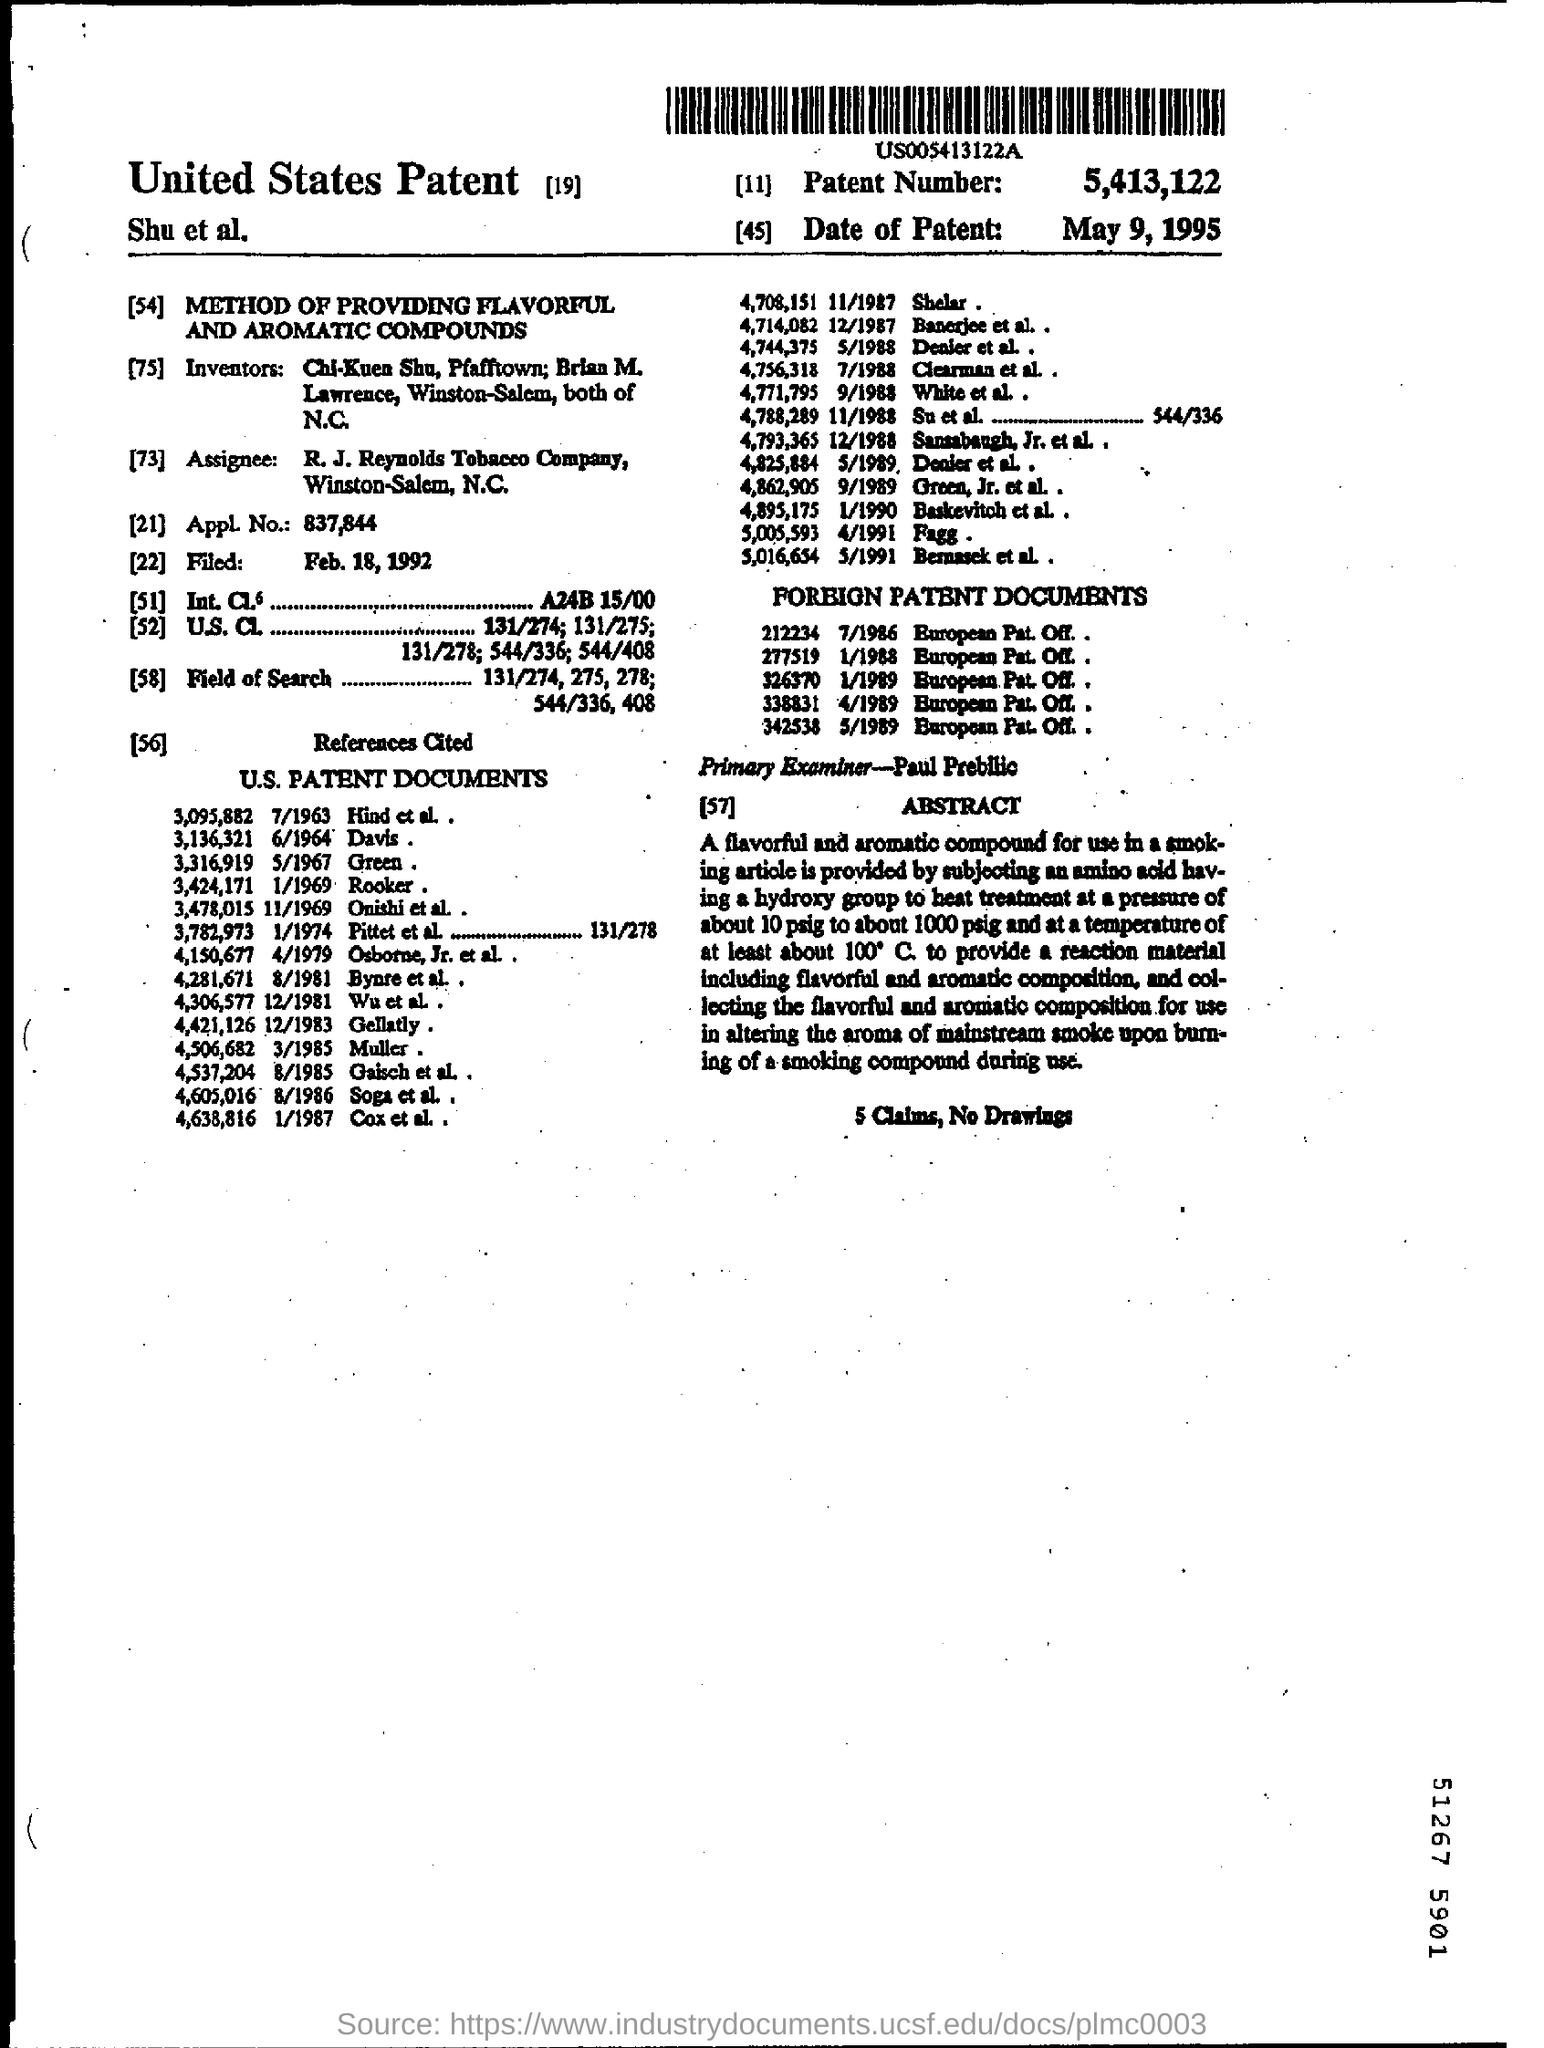What is the patent application number?
Give a very brief answer. 837,844. What is the Patent Number?
Keep it short and to the point. 5,413,122. What is the date of patent?
Provide a succinct answer. May 9,1995. Who is the Assignee?
Your answer should be compact. R.J Reynolds Tobacco Company. When was the application filed?
Offer a terse response. Feb. 18,1992. Who is the primary examiner?
Your answer should be very brief. Paul prebllic. 